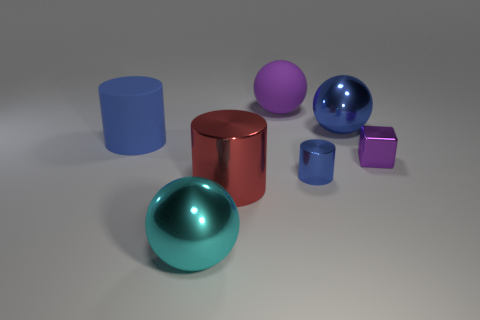How many blue spheres have the same size as the metal cube?
Make the answer very short. 0. There is a large metallic sphere that is behind the matte cylinder; is it the same color as the large matte cylinder?
Your answer should be very brief. Yes. There is a big thing that is both in front of the big blue matte cylinder and on the right side of the cyan sphere; what material is it?
Give a very brief answer. Metal. Are there more red objects than tiny metal spheres?
Provide a short and direct response. Yes. The large metallic thing to the right of the big thing that is behind the big sphere that is to the right of the big purple sphere is what color?
Provide a succinct answer. Blue. Is the material of the blue cylinder left of the big red object the same as the big blue ball?
Make the answer very short. No. Is there a large thing of the same color as the small metallic cylinder?
Keep it short and to the point. Yes. Are there any purple rubber things?
Offer a very short reply. Yes. Do the blue metallic thing right of the blue shiny cylinder and the big purple object have the same size?
Offer a very short reply. Yes. Are there fewer tiny blue things than red rubber cylinders?
Ensure brevity in your answer.  No. 